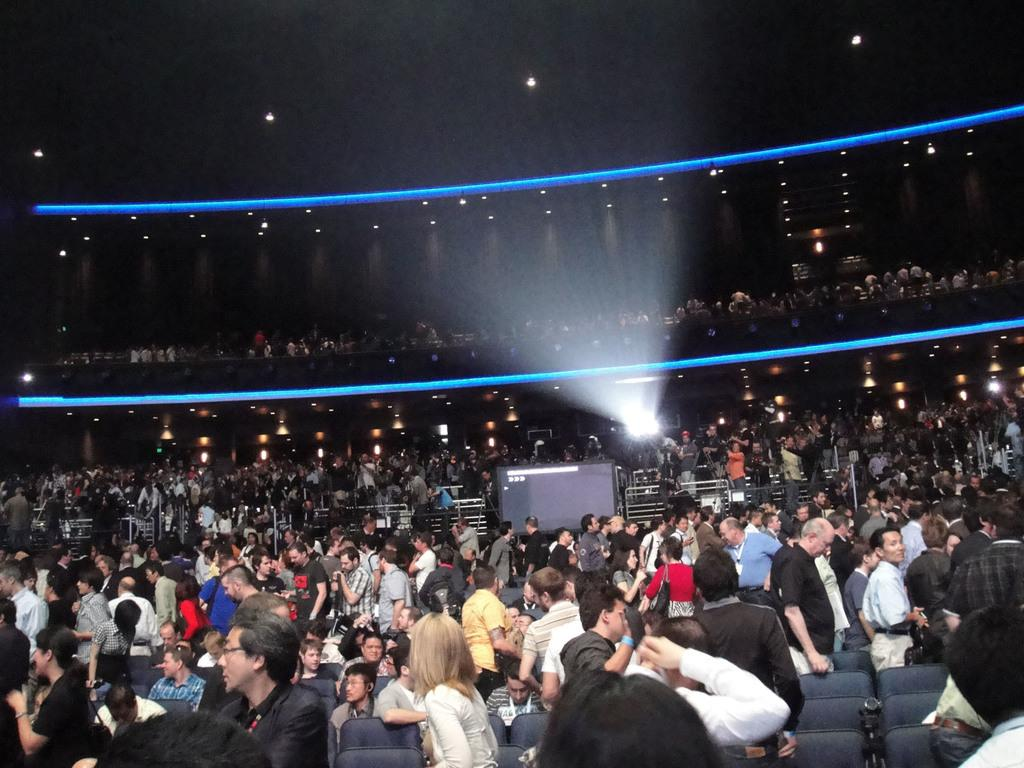What are the people in the image doing? There are people standing and sitting on chairs in the image. Can you describe the positions of the people in the image? Some people are standing, while others are sitting on chairs. What type of pie is being served on the table in the image? There is no table or pie present in the image; it only shows people standing and sitting on chairs. 